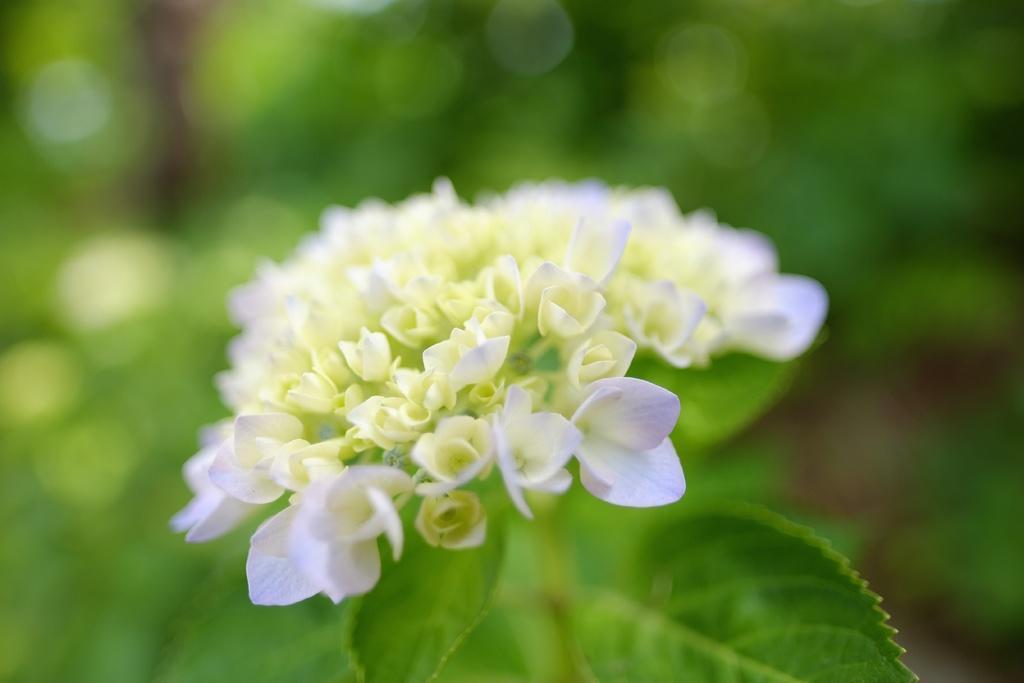In one or two sentences, can you explain what this image depicts? In the picture we can see plants to it, we can see a group of flowers which are white in color. 